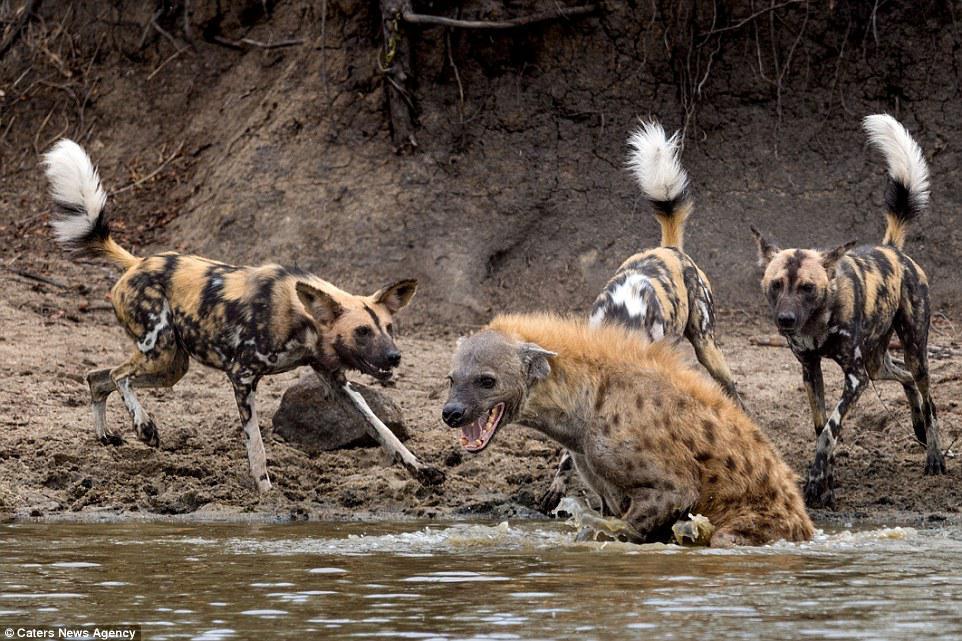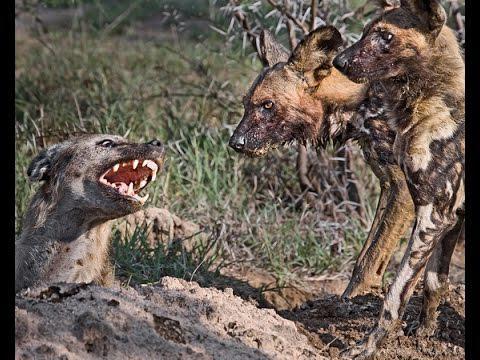The first image is the image on the left, the second image is the image on the right. Considering the images on both sides, is "In the right image, a fang-baring open-mouthed hyena on the left is facing at least one canine of a different type on the right." valid? Answer yes or no. Yes. 